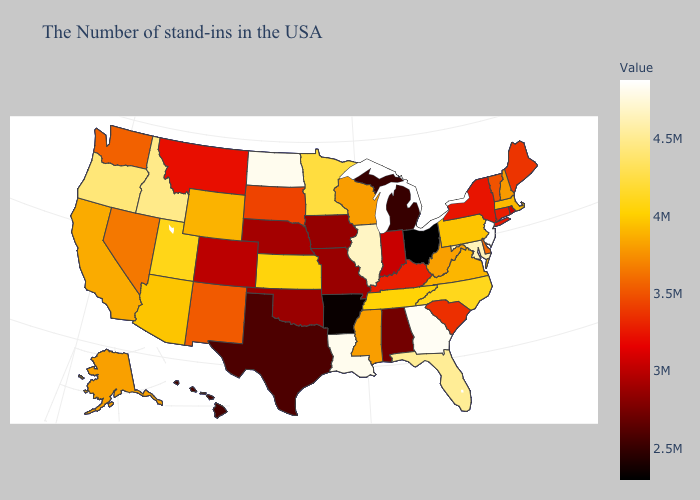Which states have the highest value in the USA?
Concise answer only. New Jersey. Which states have the lowest value in the USA?
Write a very short answer. Ohio. Among the states that border Maryland , does Delaware have the lowest value?
Write a very short answer. Yes. Does West Virginia have the lowest value in the USA?
Quick response, please. No. 